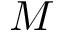Convert formula to latex. <formula><loc_0><loc_0><loc_500><loc_500>M</formula> 